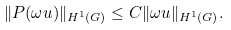Convert formula to latex. <formula><loc_0><loc_0><loc_500><loc_500>\| P ( \omega u ) \| _ { H ^ { 1 } ( G ) } \leq C \| \omega u \| _ { H ^ { 1 } ( G ) } .</formula> 